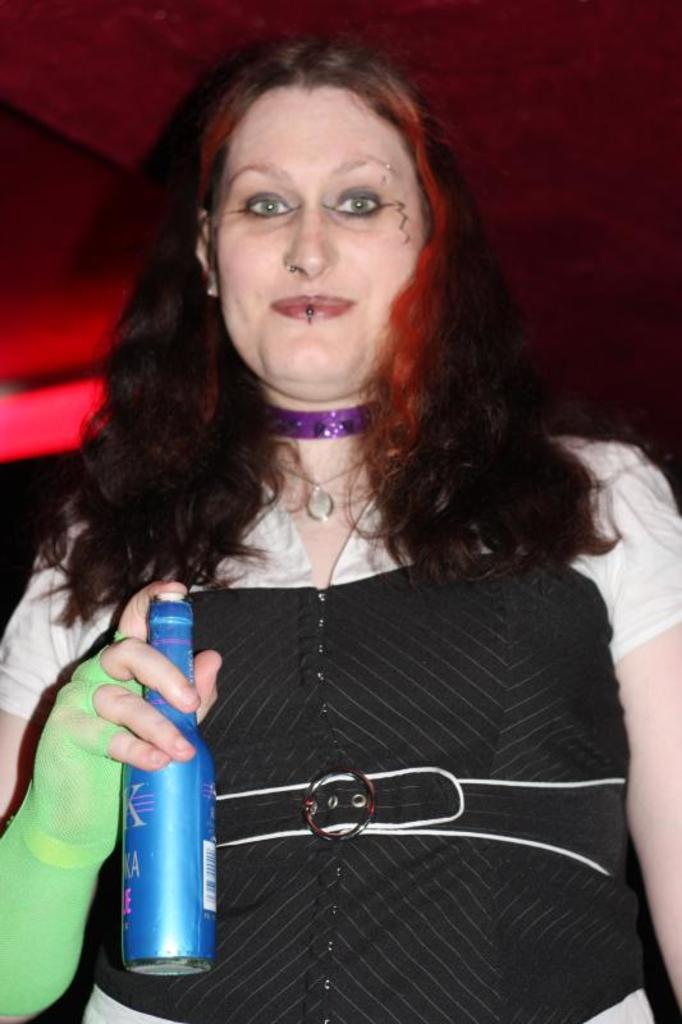Who is the main subject in the image? There is a woman in the image. What is the woman doing in the image? The woman is standing and laughing. What is the woman holding in the image? The woman is holding a bottle. What can be seen in the background of the image? There is a red color light in the background of the image. How many rabbits are hopping on the land in the image? There are no rabbits or land present in the image. What type of mint is being used to flavor the woman's drink in the image? There is no mint mentioned or visible in the image. 